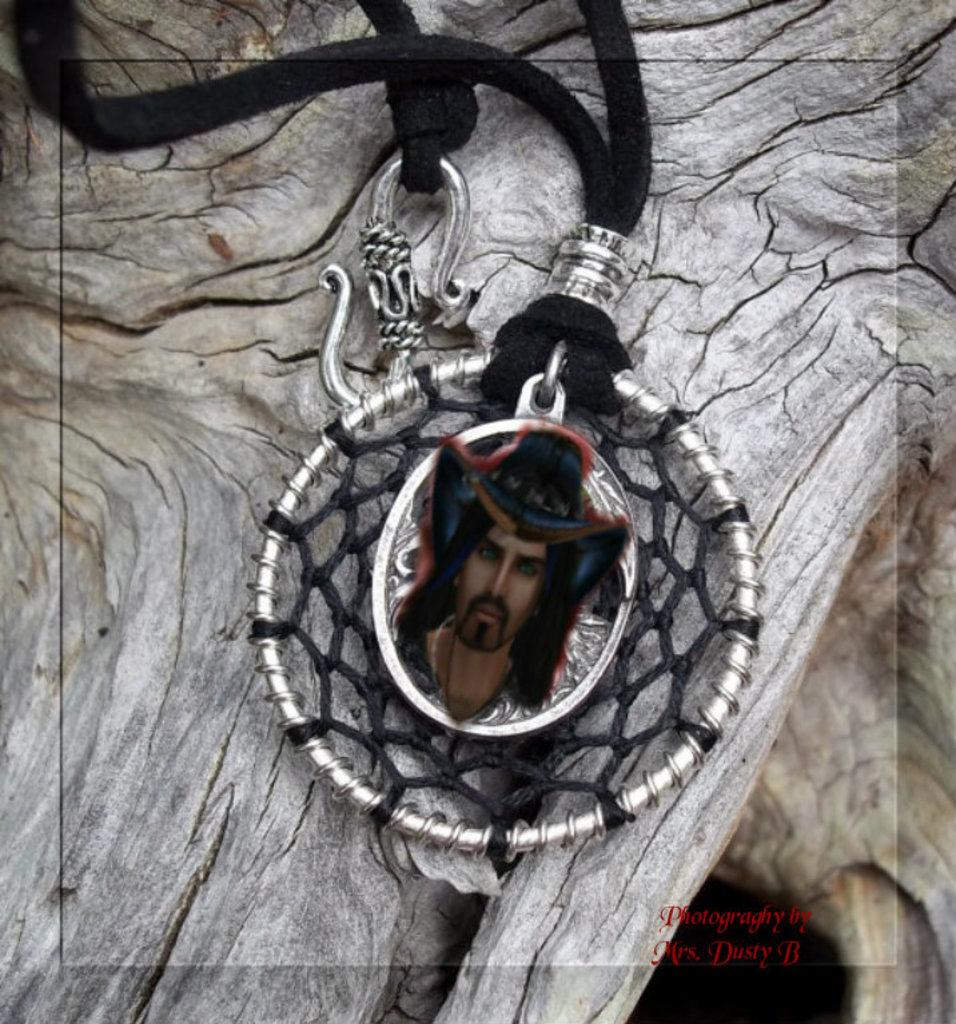What object is the main focus of the image? There is a locket in the image. Where is the locket placed? The locket is placed on a wooden surface. What can be seen on the locket? There is an image of a person on the locket. What type of stocking is hanging near the locket in the image? There is no stocking present in the image. What kind of haircut does the person in the image on the locket have? The image on the locket is too small to determine the person's haircut. 